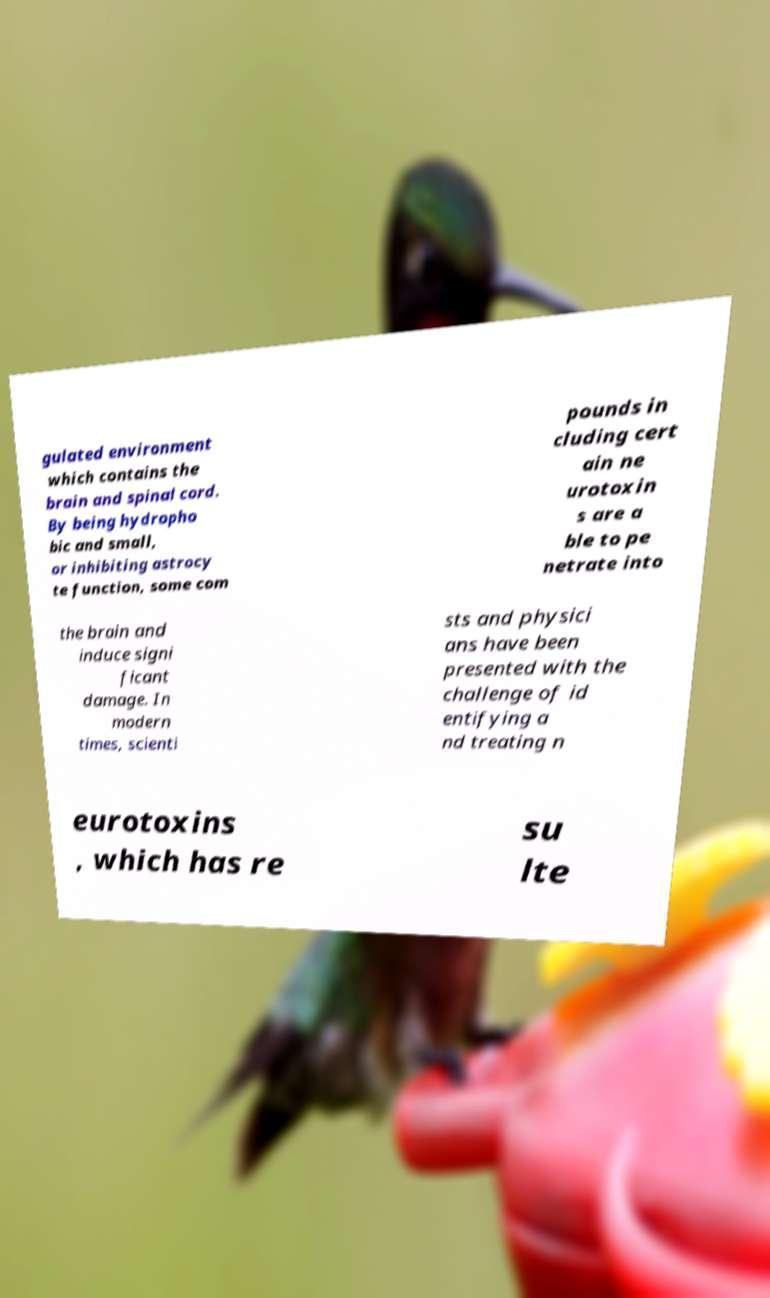Can you read and provide the text displayed in the image?This photo seems to have some interesting text. Can you extract and type it out for me? gulated environment which contains the brain and spinal cord. By being hydropho bic and small, or inhibiting astrocy te function, some com pounds in cluding cert ain ne urotoxin s are a ble to pe netrate into the brain and induce signi ficant damage. In modern times, scienti sts and physici ans have been presented with the challenge of id entifying a nd treating n eurotoxins , which has re su lte 